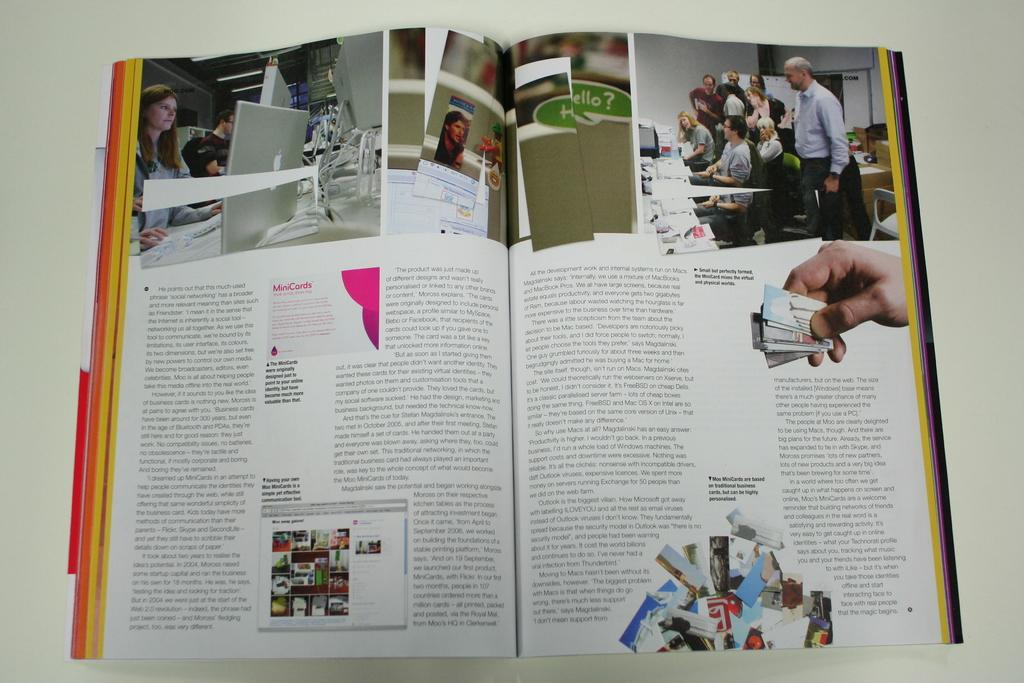Provide a one-sentence caption for the provided image. A magazine is opened up to an article that talks about the role that some forms of social media and technology can have on a business. 